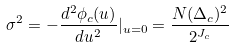<formula> <loc_0><loc_0><loc_500><loc_500>\sigma ^ { 2 } = - \frac { d ^ { 2 } \phi _ { c } ( u ) } { d u ^ { 2 } } | _ { u = 0 } = \frac { N ( \Delta _ { c } ) ^ { 2 } } { 2 ^ { J _ { c } } }</formula> 